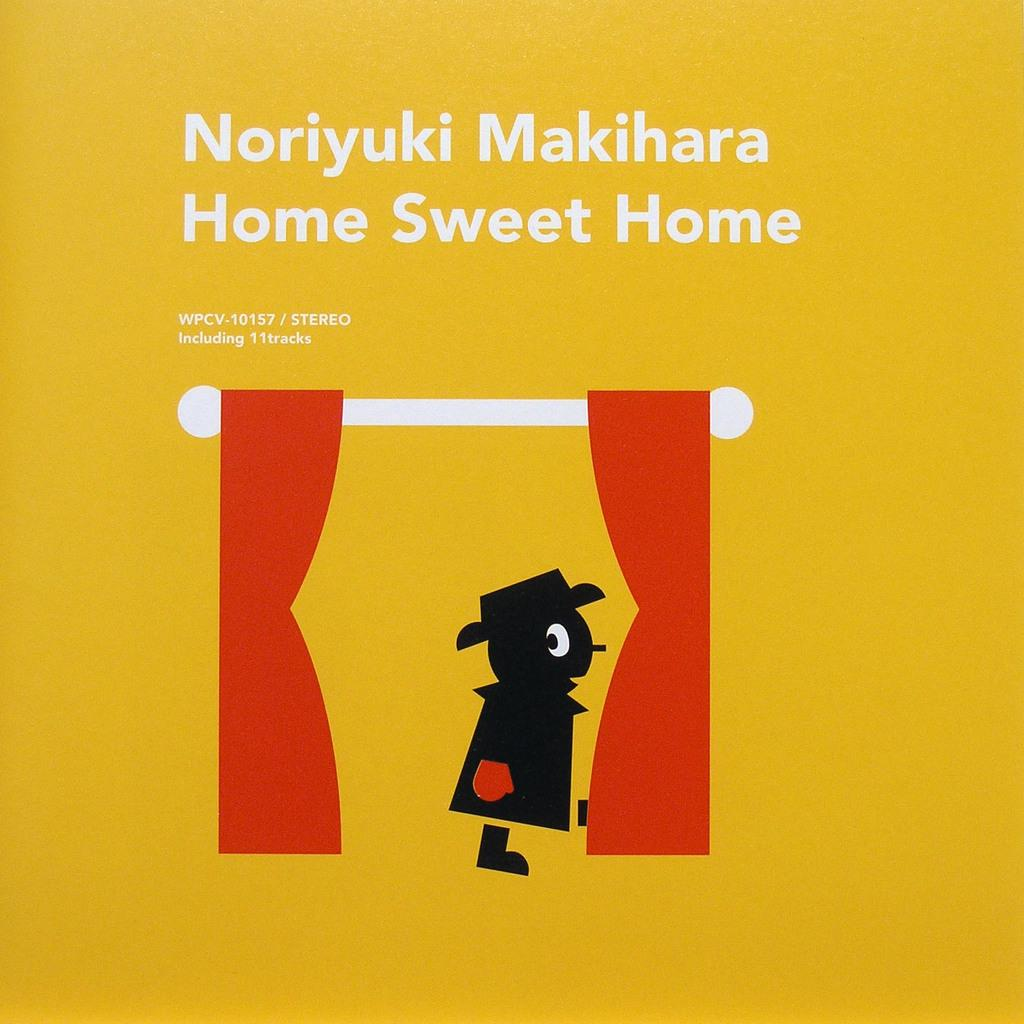What type of picture is the image? The image is an animated picture. What can be seen in the image besides the animated elements? There is a white rod, red curtains, and a person in the image. What might be used to cover or decorate a window or stage? Red curtains can be used to cover or decorate a window or stage. What is the background color of the image? The background of the image is yellow. Are there any words present in the image? Yes, there are words written in the image. What type of maid is cleaning the stick in the image? There is no maid or stick present in the image. What type of shade is covering the person in the image? There is no shade covering the person in the image; the person is visible. 